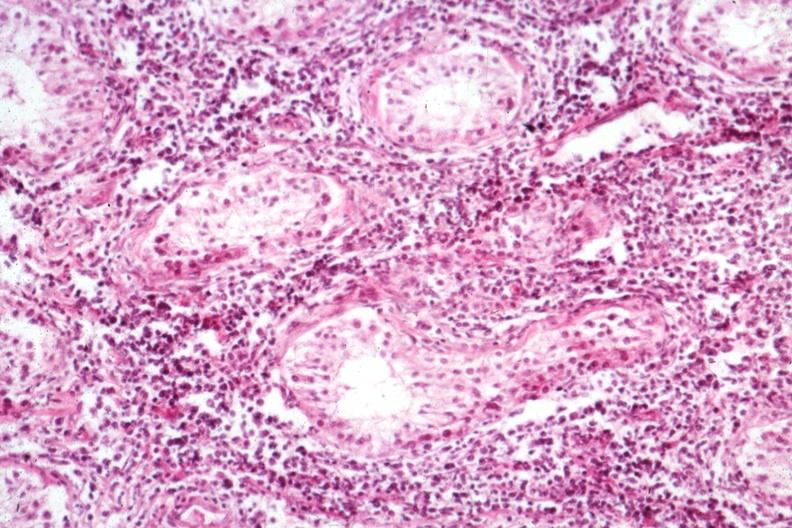what is present?
Answer the question using a single word or phrase. Malignant lymphoma 